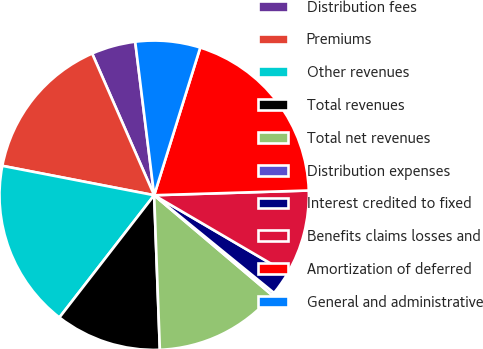<chart> <loc_0><loc_0><loc_500><loc_500><pie_chart><fcel>Distribution fees<fcel>Premiums<fcel>Other revenues<fcel>Total revenues<fcel>Total net revenues<fcel>Distribution expenses<fcel>Interest credited to fixed<fcel>Benefits claims losses and<fcel>Amortization of deferred<fcel>General and administrative<nl><fcel>4.61%<fcel>15.39%<fcel>17.55%<fcel>11.08%<fcel>13.23%<fcel>0.3%<fcel>2.45%<fcel>8.92%<fcel>19.7%<fcel>6.77%<nl></chart> 